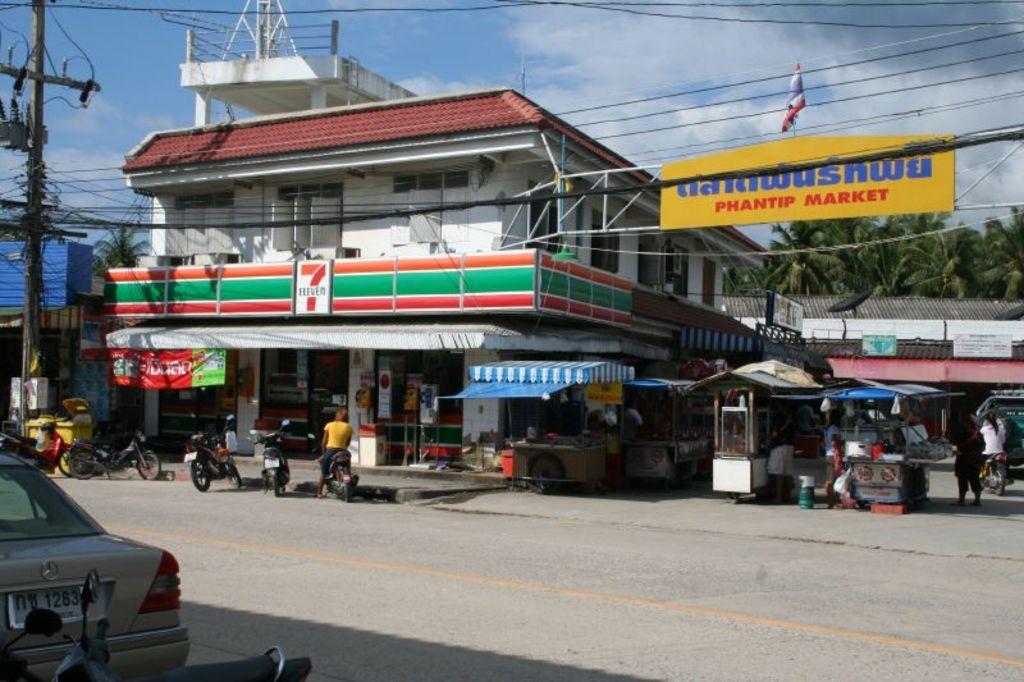Can you describe this image briefly? This is the picture of a city. In this image there are buildings, poles, hoardings and there is a flag. In the foreground there is a person sitting on the motorbike. On the right side of the image there are three persons standing and there is a person riding the motorbike. There are vehicles on the road. At the top there is sky and there are clouds. At the bottom there is a road. 